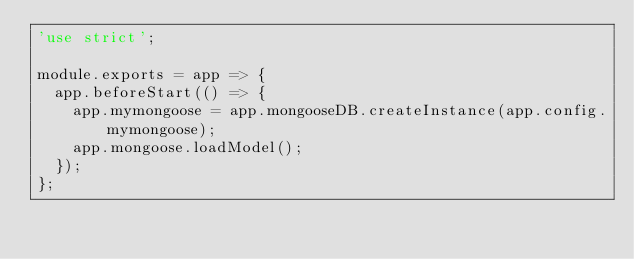<code> <loc_0><loc_0><loc_500><loc_500><_JavaScript_>'use strict';

module.exports = app => {
  app.beforeStart(() => {
    app.mymongoose = app.mongooseDB.createInstance(app.config.mymongoose);
    app.mongoose.loadModel();
  });
};
</code> 